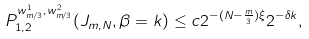<formula> <loc_0><loc_0><loc_500><loc_500>P ^ { w ^ { 1 } _ { m / 3 } , w ^ { 2 } _ { m / 3 } } _ { 1 , 2 } ( J _ { m , N } , \beta = k ) \leq c 2 ^ { - ( N - \frac { m } { 3 } ) \xi } 2 ^ { - \delta k } ,</formula> 